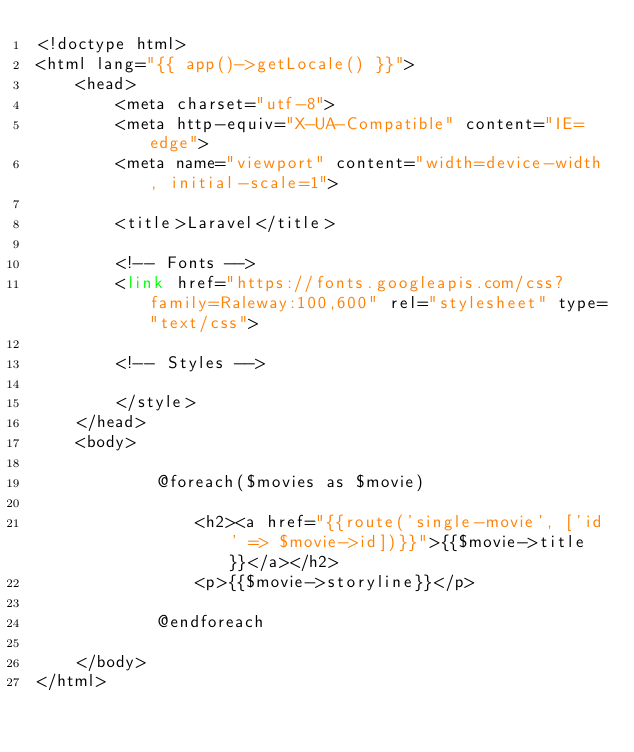<code> <loc_0><loc_0><loc_500><loc_500><_PHP_><!doctype html>
<html lang="{{ app()->getLocale() }}">
    <head>
        <meta charset="utf-8">
        <meta http-equiv="X-UA-Compatible" content="IE=edge">
        <meta name="viewport" content="width=device-width, initial-scale=1">

        <title>Laravel</title>

        <!-- Fonts -->
        <link href="https://fonts.googleapis.com/css?family=Raleway:100,600" rel="stylesheet" type="text/css">

        <!-- Styles -->
        
        </style>
    </head>
    <body>
        
            @foreach($movies as $movie)
                
                <h2><a href="{{route('single-movie', ['id' => $movie->id])}}">{{$movie->title}}</a></h2>
                <p>{{$movie->storyline}}</p>
                
            @endforeach
        
    </body>
</html>
</code> 